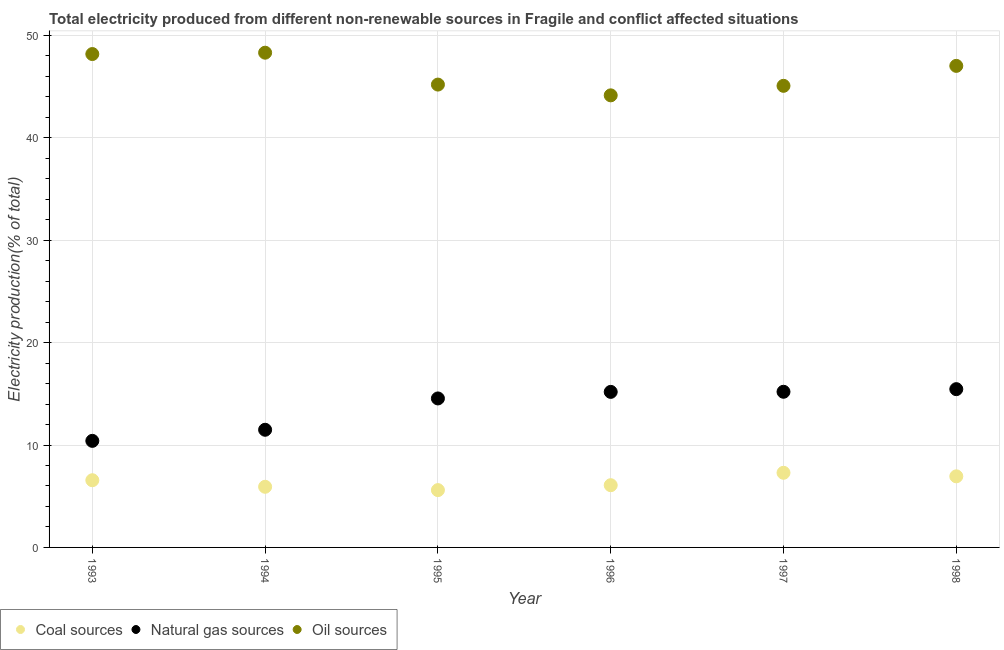How many different coloured dotlines are there?
Offer a very short reply. 3. What is the percentage of electricity produced by coal in 1997?
Your answer should be compact. 7.29. Across all years, what is the maximum percentage of electricity produced by oil sources?
Offer a terse response. 48.3. Across all years, what is the minimum percentage of electricity produced by natural gas?
Your answer should be compact. 10.4. In which year was the percentage of electricity produced by coal maximum?
Your answer should be compact. 1997. What is the total percentage of electricity produced by natural gas in the graph?
Keep it short and to the point. 82.28. What is the difference between the percentage of electricity produced by coal in 1995 and that in 1996?
Provide a succinct answer. -0.48. What is the difference between the percentage of electricity produced by natural gas in 1996 and the percentage of electricity produced by oil sources in 1998?
Your answer should be very brief. -31.83. What is the average percentage of electricity produced by coal per year?
Ensure brevity in your answer.  6.4. In the year 1996, what is the difference between the percentage of electricity produced by oil sources and percentage of electricity produced by coal?
Offer a terse response. 38.06. What is the ratio of the percentage of electricity produced by oil sources in 1995 to that in 1996?
Ensure brevity in your answer.  1.02. Is the percentage of electricity produced by oil sources in 1995 less than that in 1996?
Keep it short and to the point. No. What is the difference between the highest and the second highest percentage of electricity produced by natural gas?
Your response must be concise. 0.26. What is the difference between the highest and the lowest percentage of electricity produced by oil sources?
Your response must be concise. 4.16. Is the sum of the percentage of electricity produced by natural gas in 1994 and 1997 greater than the maximum percentage of electricity produced by coal across all years?
Your answer should be very brief. Yes. Is it the case that in every year, the sum of the percentage of electricity produced by coal and percentage of electricity produced by natural gas is greater than the percentage of electricity produced by oil sources?
Your answer should be compact. No. Is the percentage of electricity produced by coal strictly greater than the percentage of electricity produced by oil sources over the years?
Your response must be concise. No. Is the percentage of electricity produced by oil sources strictly less than the percentage of electricity produced by coal over the years?
Offer a terse response. No. How many years are there in the graph?
Keep it short and to the point. 6. Are the values on the major ticks of Y-axis written in scientific E-notation?
Your answer should be compact. No. Does the graph contain any zero values?
Offer a terse response. No. How many legend labels are there?
Ensure brevity in your answer.  3. What is the title of the graph?
Make the answer very short. Total electricity produced from different non-renewable sources in Fragile and conflict affected situations. What is the Electricity production(% of total) in Coal sources in 1993?
Give a very brief answer. 6.56. What is the Electricity production(% of total) of Natural gas sources in 1993?
Offer a very short reply. 10.4. What is the Electricity production(% of total) of Oil sources in 1993?
Give a very brief answer. 48.17. What is the Electricity production(% of total) in Coal sources in 1994?
Provide a short and direct response. 5.92. What is the Electricity production(% of total) of Natural gas sources in 1994?
Provide a short and direct response. 11.49. What is the Electricity production(% of total) in Oil sources in 1994?
Offer a terse response. 48.3. What is the Electricity production(% of total) in Coal sources in 1995?
Your answer should be compact. 5.6. What is the Electricity production(% of total) in Natural gas sources in 1995?
Give a very brief answer. 14.55. What is the Electricity production(% of total) of Oil sources in 1995?
Ensure brevity in your answer.  45.19. What is the Electricity production(% of total) in Coal sources in 1996?
Make the answer very short. 6.08. What is the Electricity production(% of total) of Natural gas sources in 1996?
Your answer should be very brief. 15.19. What is the Electricity production(% of total) of Oil sources in 1996?
Offer a very short reply. 44.14. What is the Electricity production(% of total) of Coal sources in 1997?
Give a very brief answer. 7.29. What is the Electricity production(% of total) of Natural gas sources in 1997?
Your response must be concise. 15.2. What is the Electricity production(% of total) in Oil sources in 1997?
Provide a short and direct response. 45.07. What is the Electricity production(% of total) of Coal sources in 1998?
Ensure brevity in your answer.  6.94. What is the Electricity production(% of total) of Natural gas sources in 1998?
Keep it short and to the point. 15.45. What is the Electricity production(% of total) of Oil sources in 1998?
Offer a very short reply. 47.02. Across all years, what is the maximum Electricity production(% of total) of Coal sources?
Your response must be concise. 7.29. Across all years, what is the maximum Electricity production(% of total) of Natural gas sources?
Make the answer very short. 15.45. Across all years, what is the maximum Electricity production(% of total) of Oil sources?
Offer a terse response. 48.3. Across all years, what is the minimum Electricity production(% of total) in Coal sources?
Give a very brief answer. 5.6. Across all years, what is the minimum Electricity production(% of total) of Natural gas sources?
Provide a succinct answer. 10.4. Across all years, what is the minimum Electricity production(% of total) in Oil sources?
Your response must be concise. 44.14. What is the total Electricity production(% of total) in Coal sources in the graph?
Offer a terse response. 38.38. What is the total Electricity production(% of total) of Natural gas sources in the graph?
Keep it short and to the point. 82.28. What is the total Electricity production(% of total) of Oil sources in the graph?
Give a very brief answer. 277.89. What is the difference between the Electricity production(% of total) of Coal sources in 1993 and that in 1994?
Your answer should be very brief. 0.64. What is the difference between the Electricity production(% of total) of Natural gas sources in 1993 and that in 1994?
Provide a succinct answer. -1.08. What is the difference between the Electricity production(% of total) of Oil sources in 1993 and that in 1994?
Offer a terse response. -0.13. What is the difference between the Electricity production(% of total) in Coal sources in 1993 and that in 1995?
Ensure brevity in your answer.  0.96. What is the difference between the Electricity production(% of total) in Natural gas sources in 1993 and that in 1995?
Give a very brief answer. -4.14. What is the difference between the Electricity production(% of total) in Oil sources in 1993 and that in 1995?
Ensure brevity in your answer.  2.98. What is the difference between the Electricity production(% of total) of Coal sources in 1993 and that in 1996?
Offer a very short reply. 0.48. What is the difference between the Electricity production(% of total) of Natural gas sources in 1993 and that in 1996?
Give a very brief answer. -4.78. What is the difference between the Electricity production(% of total) of Oil sources in 1993 and that in 1996?
Offer a very short reply. 4.03. What is the difference between the Electricity production(% of total) in Coal sources in 1993 and that in 1997?
Offer a terse response. -0.73. What is the difference between the Electricity production(% of total) of Natural gas sources in 1993 and that in 1997?
Make the answer very short. -4.79. What is the difference between the Electricity production(% of total) of Oil sources in 1993 and that in 1997?
Provide a short and direct response. 3.1. What is the difference between the Electricity production(% of total) of Coal sources in 1993 and that in 1998?
Offer a very short reply. -0.38. What is the difference between the Electricity production(% of total) of Natural gas sources in 1993 and that in 1998?
Make the answer very short. -5.05. What is the difference between the Electricity production(% of total) of Oil sources in 1993 and that in 1998?
Provide a short and direct response. 1.15. What is the difference between the Electricity production(% of total) in Coal sources in 1994 and that in 1995?
Offer a very short reply. 0.32. What is the difference between the Electricity production(% of total) in Natural gas sources in 1994 and that in 1995?
Offer a terse response. -3.06. What is the difference between the Electricity production(% of total) in Oil sources in 1994 and that in 1995?
Provide a short and direct response. 3.11. What is the difference between the Electricity production(% of total) of Coal sources in 1994 and that in 1996?
Your response must be concise. -0.15. What is the difference between the Electricity production(% of total) of Natural gas sources in 1994 and that in 1996?
Keep it short and to the point. -3.7. What is the difference between the Electricity production(% of total) in Oil sources in 1994 and that in 1996?
Give a very brief answer. 4.16. What is the difference between the Electricity production(% of total) of Coal sources in 1994 and that in 1997?
Offer a terse response. -1.37. What is the difference between the Electricity production(% of total) in Natural gas sources in 1994 and that in 1997?
Ensure brevity in your answer.  -3.71. What is the difference between the Electricity production(% of total) in Oil sources in 1994 and that in 1997?
Give a very brief answer. 3.24. What is the difference between the Electricity production(% of total) in Coal sources in 1994 and that in 1998?
Your response must be concise. -1.02. What is the difference between the Electricity production(% of total) of Natural gas sources in 1994 and that in 1998?
Your answer should be very brief. -3.97. What is the difference between the Electricity production(% of total) in Oil sources in 1994 and that in 1998?
Your answer should be compact. 1.29. What is the difference between the Electricity production(% of total) of Coal sources in 1995 and that in 1996?
Provide a short and direct response. -0.48. What is the difference between the Electricity production(% of total) of Natural gas sources in 1995 and that in 1996?
Your response must be concise. -0.64. What is the difference between the Electricity production(% of total) of Oil sources in 1995 and that in 1996?
Provide a succinct answer. 1.05. What is the difference between the Electricity production(% of total) in Coal sources in 1995 and that in 1997?
Keep it short and to the point. -1.69. What is the difference between the Electricity production(% of total) in Natural gas sources in 1995 and that in 1997?
Offer a terse response. -0.65. What is the difference between the Electricity production(% of total) of Oil sources in 1995 and that in 1997?
Your answer should be compact. 0.12. What is the difference between the Electricity production(% of total) of Coal sources in 1995 and that in 1998?
Keep it short and to the point. -1.35. What is the difference between the Electricity production(% of total) in Natural gas sources in 1995 and that in 1998?
Offer a very short reply. -0.91. What is the difference between the Electricity production(% of total) in Oil sources in 1995 and that in 1998?
Your answer should be compact. -1.83. What is the difference between the Electricity production(% of total) of Coal sources in 1996 and that in 1997?
Keep it short and to the point. -1.21. What is the difference between the Electricity production(% of total) of Natural gas sources in 1996 and that in 1997?
Your response must be concise. -0.01. What is the difference between the Electricity production(% of total) in Oil sources in 1996 and that in 1997?
Offer a very short reply. -0.93. What is the difference between the Electricity production(% of total) in Coal sources in 1996 and that in 1998?
Your response must be concise. -0.87. What is the difference between the Electricity production(% of total) in Natural gas sources in 1996 and that in 1998?
Your response must be concise. -0.27. What is the difference between the Electricity production(% of total) in Oil sources in 1996 and that in 1998?
Your answer should be very brief. -2.88. What is the difference between the Electricity production(% of total) of Coal sources in 1997 and that in 1998?
Provide a succinct answer. 0.35. What is the difference between the Electricity production(% of total) of Natural gas sources in 1997 and that in 1998?
Provide a short and direct response. -0.26. What is the difference between the Electricity production(% of total) of Oil sources in 1997 and that in 1998?
Provide a succinct answer. -1.95. What is the difference between the Electricity production(% of total) of Coal sources in 1993 and the Electricity production(% of total) of Natural gas sources in 1994?
Your answer should be compact. -4.93. What is the difference between the Electricity production(% of total) of Coal sources in 1993 and the Electricity production(% of total) of Oil sources in 1994?
Provide a short and direct response. -41.74. What is the difference between the Electricity production(% of total) in Natural gas sources in 1993 and the Electricity production(% of total) in Oil sources in 1994?
Offer a terse response. -37.9. What is the difference between the Electricity production(% of total) of Coal sources in 1993 and the Electricity production(% of total) of Natural gas sources in 1995?
Offer a terse response. -7.99. What is the difference between the Electricity production(% of total) of Coal sources in 1993 and the Electricity production(% of total) of Oil sources in 1995?
Provide a short and direct response. -38.63. What is the difference between the Electricity production(% of total) in Natural gas sources in 1993 and the Electricity production(% of total) in Oil sources in 1995?
Offer a very short reply. -34.79. What is the difference between the Electricity production(% of total) in Coal sources in 1993 and the Electricity production(% of total) in Natural gas sources in 1996?
Ensure brevity in your answer.  -8.63. What is the difference between the Electricity production(% of total) of Coal sources in 1993 and the Electricity production(% of total) of Oil sources in 1996?
Your response must be concise. -37.58. What is the difference between the Electricity production(% of total) of Natural gas sources in 1993 and the Electricity production(% of total) of Oil sources in 1996?
Your answer should be compact. -33.74. What is the difference between the Electricity production(% of total) of Coal sources in 1993 and the Electricity production(% of total) of Natural gas sources in 1997?
Offer a terse response. -8.64. What is the difference between the Electricity production(% of total) in Coal sources in 1993 and the Electricity production(% of total) in Oil sources in 1997?
Offer a terse response. -38.51. What is the difference between the Electricity production(% of total) of Natural gas sources in 1993 and the Electricity production(% of total) of Oil sources in 1997?
Provide a short and direct response. -34.66. What is the difference between the Electricity production(% of total) of Coal sources in 1993 and the Electricity production(% of total) of Natural gas sources in 1998?
Your response must be concise. -8.89. What is the difference between the Electricity production(% of total) in Coal sources in 1993 and the Electricity production(% of total) in Oil sources in 1998?
Offer a very short reply. -40.46. What is the difference between the Electricity production(% of total) of Natural gas sources in 1993 and the Electricity production(% of total) of Oil sources in 1998?
Offer a very short reply. -36.61. What is the difference between the Electricity production(% of total) in Coal sources in 1994 and the Electricity production(% of total) in Natural gas sources in 1995?
Offer a terse response. -8.63. What is the difference between the Electricity production(% of total) in Coal sources in 1994 and the Electricity production(% of total) in Oil sources in 1995?
Provide a short and direct response. -39.27. What is the difference between the Electricity production(% of total) in Natural gas sources in 1994 and the Electricity production(% of total) in Oil sources in 1995?
Your response must be concise. -33.7. What is the difference between the Electricity production(% of total) in Coal sources in 1994 and the Electricity production(% of total) in Natural gas sources in 1996?
Make the answer very short. -9.27. What is the difference between the Electricity production(% of total) in Coal sources in 1994 and the Electricity production(% of total) in Oil sources in 1996?
Ensure brevity in your answer.  -38.22. What is the difference between the Electricity production(% of total) of Natural gas sources in 1994 and the Electricity production(% of total) of Oil sources in 1996?
Your response must be concise. -32.65. What is the difference between the Electricity production(% of total) in Coal sources in 1994 and the Electricity production(% of total) in Natural gas sources in 1997?
Your answer should be compact. -9.28. What is the difference between the Electricity production(% of total) in Coal sources in 1994 and the Electricity production(% of total) in Oil sources in 1997?
Make the answer very short. -39.15. What is the difference between the Electricity production(% of total) of Natural gas sources in 1994 and the Electricity production(% of total) of Oil sources in 1997?
Your response must be concise. -33.58. What is the difference between the Electricity production(% of total) in Coal sources in 1994 and the Electricity production(% of total) in Natural gas sources in 1998?
Offer a terse response. -9.53. What is the difference between the Electricity production(% of total) in Coal sources in 1994 and the Electricity production(% of total) in Oil sources in 1998?
Your answer should be very brief. -41.1. What is the difference between the Electricity production(% of total) of Natural gas sources in 1994 and the Electricity production(% of total) of Oil sources in 1998?
Your answer should be compact. -35.53. What is the difference between the Electricity production(% of total) in Coal sources in 1995 and the Electricity production(% of total) in Natural gas sources in 1996?
Provide a short and direct response. -9.59. What is the difference between the Electricity production(% of total) in Coal sources in 1995 and the Electricity production(% of total) in Oil sources in 1996?
Offer a very short reply. -38.54. What is the difference between the Electricity production(% of total) of Natural gas sources in 1995 and the Electricity production(% of total) of Oil sources in 1996?
Give a very brief answer. -29.59. What is the difference between the Electricity production(% of total) of Coal sources in 1995 and the Electricity production(% of total) of Natural gas sources in 1997?
Make the answer very short. -9.6. What is the difference between the Electricity production(% of total) in Coal sources in 1995 and the Electricity production(% of total) in Oil sources in 1997?
Offer a very short reply. -39.47. What is the difference between the Electricity production(% of total) in Natural gas sources in 1995 and the Electricity production(% of total) in Oil sources in 1997?
Offer a terse response. -30.52. What is the difference between the Electricity production(% of total) in Coal sources in 1995 and the Electricity production(% of total) in Natural gas sources in 1998?
Offer a terse response. -9.86. What is the difference between the Electricity production(% of total) of Coal sources in 1995 and the Electricity production(% of total) of Oil sources in 1998?
Ensure brevity in your answer.  -41.42. What is the difference between the Electricity production(% of total) of Natural gas sources in 1995 and the Electricity production(% of total) of Oil sources in 1998?
Your answer should be compact. -32.47. What is the difference between the Electricity production(% of total) in Coal sources in 1996 and the Electricity production(% of total) in Natural gas sources in 1997?
Offer a very short reply. -9.12. What is the difference between the Electricity production(% of total) in Coal sources in 1996 and the Electricity production(% of total) in Oil sources in 1997?
Keep it short and to the point. -38.99. What is the difference between the Electricity production(% of total) of Natural gas sources in 1996 and the Electricity production(% of total) of Oil sources in 1997?
Offer a terse response. -29.88. What is the difference between the Electricity production(% of total) in Coal sources in 1996 and the Electricity production(% of total) in Natural gas sources in 1998?
Your answer should be compact. -9.38. What is the difference between the Electricity production(% of total) in Coal sources in 1996 and the Electricity production(% of total) in Oil sources in 1998?
Ensure brevity in your answer.  -40.94. What is the difference between the Electricity production(% of total) of Natural gas sources in 1996 and the Electricity production(% of total) of Oil sources in 1998?
Provide a succinct answer. -31.83. What is the difference between the Electricity production(% of total) of Coal sources in 1997 and the Electricity production(% of total) of Natural gas sources in 1998?
Your answer should be compact. -8.17. What is the difference between the Electricity production(% of total) of Coal sources in 1997 and the Electricity production(% of total) of Oil sources in 1998?
Offer a terse response. -39.73. What is the difference between the Electricity production(% of total) in Natural gas sources in 1997 and the Electricity production(% of total) in Oil sources in 1998?
Provide a succinct answer. -31.82. What is the average Electricity production(% of total) of Coal sources per year?
Offer a very short reply. 6.4. What is the average Electricity production(% of total) in Natural gas sources per year?
Your answer should be very brief. 13.71. What is the average Electricity production(% of total) in Oil sources per year?
Ensure brevity in your answer.  46.31. In the year 1993, what is the difference between the Electricity production(% of total) of Coal sources and Electricity production(% of total) of Natural gas sources?
Provide a short and direct response. -3.84. In the year 1993, what is the difference between the Electricity production(% of total) in Coal sources and Electricity production(% of total) in Oil sources?
Keep it short and to the point. -41.61. In the year 1993, what is the difference between the Electricity production(% of total) of Natural gas sources and Electricity production(% of total) of Oil sources?
Provide a succinct answer. -37.77. In the year 1994, what is the difference between the Electricity production(% of total) of Coal sources and Electricity production(% of total) of Natural gas sources?
Make the answer very short. -5.57. In the year 1994, what is the difference between the Electricity production(% of total) in Coal sources and Electricity production(% of total) in Oil sources?
Make the answer very short. -42.38. In the year 1994, what is the difference between the Electricity production(% of total) in Natural gas sources and Electricity production(% of total) in Oil sources?
Your answer should be compact. -36.82. In the year 1995, what is the difference between the Electricity production(% of total) of Coal sources and Electricity production(% of total) of Natural gas sources?
Make the answer very short. -8.95. In the year 1995, what is the difference between the Electricity production(% of total) of Coal sources and Electricity production(% of total) of Oil sources?
Ensure brevity in your answer.  -39.59. In the year 1995, what is the difference between the Electricity production(% of total) of Natural gas sources and Electricity production(% of total) of Oil sources?
Your answer should be compact. -30.64. In the year 1996, what is the difference between the Electricity production(% of total) in Coal sources and Electricity production(% of total) in Natural gas sources?
Your answer should be very brief. -9.11. In the year 1996, what is the difference between the Electricity production(% of total) of Coal sources and Electricity production(% of total) of Oil sources?
Offer a very short reply. -38.06. In the year 1996, what is the difference between the Electricity production(% of total) of Natural gas sources and Electricity production(% of total) of Oil sources?
Your answer should be very brief. -28.95. In the year 1997, what is the difference between the Electricity production(% of total) in Coal sources and Electricity production(% of total) in Natural gas sources?
Make the answer very short. -7.91. In the year 1997, what is the difference between the Electricity production(% of total) in Coal sources and Electricity production(% of total) in Oil sources?
Your answer should be compact. -37.78. In the year 1997, what is the difference between the Electricity production(% of total) in Natural gas sources and Electricity production(% of total) in Oil sources?
Offer a terse response. -29.87. In the year 1998, what is the difference between the Electricity production(% of total) of Coal sources and Electricity production(% of total) of Natural gas sources?
Keep it short and to the point. -8.51. In the year 1998, what is the difference between the Electricity production(% of total) in Coal sources and Electricity production(% of total) in Oil sources?
Your response must be concise. -40.08. In the year 1998, what is the difference between the Electricity production(% of total) of Natural gas sources and Electricity production(% of total) of Oil sources?
Provide a short and direct response. -31.56. What is the ratio of the Electricity production(% of total) in Coal sources in 1993 to that in 1994?
Make the answer very short. 1.11. What is the ratio of the Electricity production(% of total) of Natural gas sources in 1993 to that in 1994?
Provide a succinct answer. 0.91. What is the ratio of the Electricity production(% of total) of Coal sources in 1993 to that in 1995?
Provide a short and direct response. 1.17. What is the ratio of the Electricity production(% of total) of Natural gas sources in 1993 to that in 1995?
Your answer should be compact. 0.72. What is the ratio of the Electricity production(% of total) of Oil sources in 1993 to that in 1995?
Your response must be concise. 1.07. What is the ratio of the Electricity production(% of total) of Coal sources in 1993 to that in 1996?
Give a very brief answer. 1.08. What is the ratio of the Electricity production(% of total) of Natural gas sources in 1993 to that in 1996?
Keep it short and to the point. 0.69. What is the ratio of the Electricity production(% of total) of Oil sources in 1993 to that in 1996?
Your response must be concise. 1.09. What is the ratio of the Electricity production(% of total) in Coal sources in 1993 to that in 1997?
Your answer should be very brief. 0.9. What is the ratio of the Electricity production(% of total) in Natural gas sources in 1993 to that in 1997?
Your response must be concise. 0.68. What is the ratio of the Electricity production(% of total) of Oil sources in 1993 to that in 1997?
Your answer should be very brief. 1.07. What is the ratio of the Electricity production(% of total) of Coal sources in 1993 to that in 1998?
Your response must be concise. 0.95. What is the ratio of the Electricity production(% of total) in Natural gas sources in 1993 to that in 1998?
Offer a very short reply. 0.67. What is the ratio of the Electricity production(% of total) in Oil sources in 1993 to that in 1998?
Your answer should be compact. 1.02. What is the ratio of the Electricity production(% of total) in Coal sources in 1994 to that in 1995?
Offer a terse response. 1.06. What is the ratio of the Electricity production(% of total) of Natural gas sources in 1994 to that in 1995?
Make the answer very short. 0.79. What is the ratio of the Electricity production(% of total) of Oil sources in 1994 to that in 1995?
Give a very brief answer. 1.07. What is the ratio of the Electricity production(% of total) of Coal sources in 1994 to that in 1996?
Your response must be concise. 0.97. What is the ratio of the Electricity production(% of total) in Natural gas sources in 1994 to that in 1996?
Offer a very short reply. 0.76. What is the ratio of the Electricity production(% of total) of Oil sources in 1994 to that in 1996?
Your response must be concise. 1.09. What is the ratio of the Electricity production(% of total) of Coal sources in 1994 to that in 1997?
Provide a succinct answer. 0.81. What is the ratio of the Electricity production(% of total) in Natural gas sources in 1994 to that in 1997?
Ensure brevity in your answer.  0.76. What is the ratio of the Electricity production(% of total) in Oil sources in 1994 to that in 1997?
Provide a succinct answer. 1.07. What is the ratio of the Electricity production(% of total) in Coal sources in 1994 to that in 1998?
Ensure brevity in your answer.  0.85. What is the ratio of the Electricity production(% of total) in Natural gas sources in 1994 to that in 1998?
Give a very brief answer. 0.74. What is the ratio of the Electricity production(% of total) of Oil sources in 1994 to that in 1998?
Your answer should be very brief. 1.03. What is the ratio of the Electricity production(% of total) in Coal sources in 1995 to that in 1996?
Give a very brief answer. 0.92. What is the ratio of the Electricity production(% of total) of Natural gas sources in 1995 to that in 1996?
Your response must be concise. 0.96. What is the ratio of the Electricity production(% of total) in Oil sources in 1995 to that in 1996?
Your answer should be compact. 1.02. What is the ratio of the Electricity production(% of total) of Coal sources in 1995 to that in 1997?
Give a very brief answer. 0.77. What is the ratio of the Electricity production(% of total) of Natural gas sources in 1995 to that in 1997?
Your answer should be compact. 0.96. What is the ratio of the Electricity production(% of total) in Oil sources in 1995 to that in 1997?
Offer a very short reply. 1. What is the ratio of the Electricity production(% of total) in Coal sources in 1995 to that in 1998?
Offer a terse response. 0.81. What is the ratio of the Electricity production(% of total) of Natural gas sources in 1995 to that in 1998?
Provide a short and direct response. 0.94. What is the ratio of the Electricity production(% of total) of Oil sources in 1995 to that in 1998?
Provide a short and direct response. 0.96. What is the ratio of the Electricity production(% of total) in Coal sources in 1996 to that in 1997?
Provide a short and direct response. 0.83. What is the ratio of the Electricity production(% of total) in Natural gas sources in 1996 to that in 1997?
Your answer should be compact. 1. What is the ratio of the Electricity production(% of total) of Oil sources in 1996 to that in 1997?
Offer a very short reply. 0.98. What is the ratio of the Electricity production(% of total) in Coal sources in 1996 to that in 1998?
Keep it short and to the point. 0.88. What is the ratio of the Electricity production(% of total) of Natural gas sources in 1996 to that in 1998?
Provide a short and direct response. 0.98. What is the ratio of the Electricity production(% of total) in Oil sources in 1996 to that in 1998?
Offer a very short reply. 0.94. What is the ratio of the Electricity production(% of total) of Coal sources in 1997 to that in 1998?
Provide a short and direct response. 1.05. What is the ratio of the Electricity production(% of total) in Natural gas sources in 1997 to that in 1998?
Give a very brief answer. 0.98. What is the ratio of the Electricity production(% of total) of Oil sources in 1997 to that in 1998?
Your response must be concise. 0.96. What is the difference between the highest and the second highest Electricity production(% of total) in Coal sources?
Offer a terse response. 0.35. What is the difference between the highest and the second highest Electricity production(% of total) in Natural gas sources?
Offer a very short reply. 0.26. What is the difference between the highest and the second highest Electricity production(% of total) in Oil sources?
Make the answer very short. 0.13. What is the difference between the highest and the lowest Electricity production(% of total) in Coal sources?
Keep it short and to the point. 1.69. What is the difference between the highest and the lowest Electricity production(% of total) in Natural gas sources?
Give a very brief answer. 5.05. What is the difference between the highest and the lowest Electricity production(% of total) of Oil sources?
Provide a short and direct response. 4.16. 